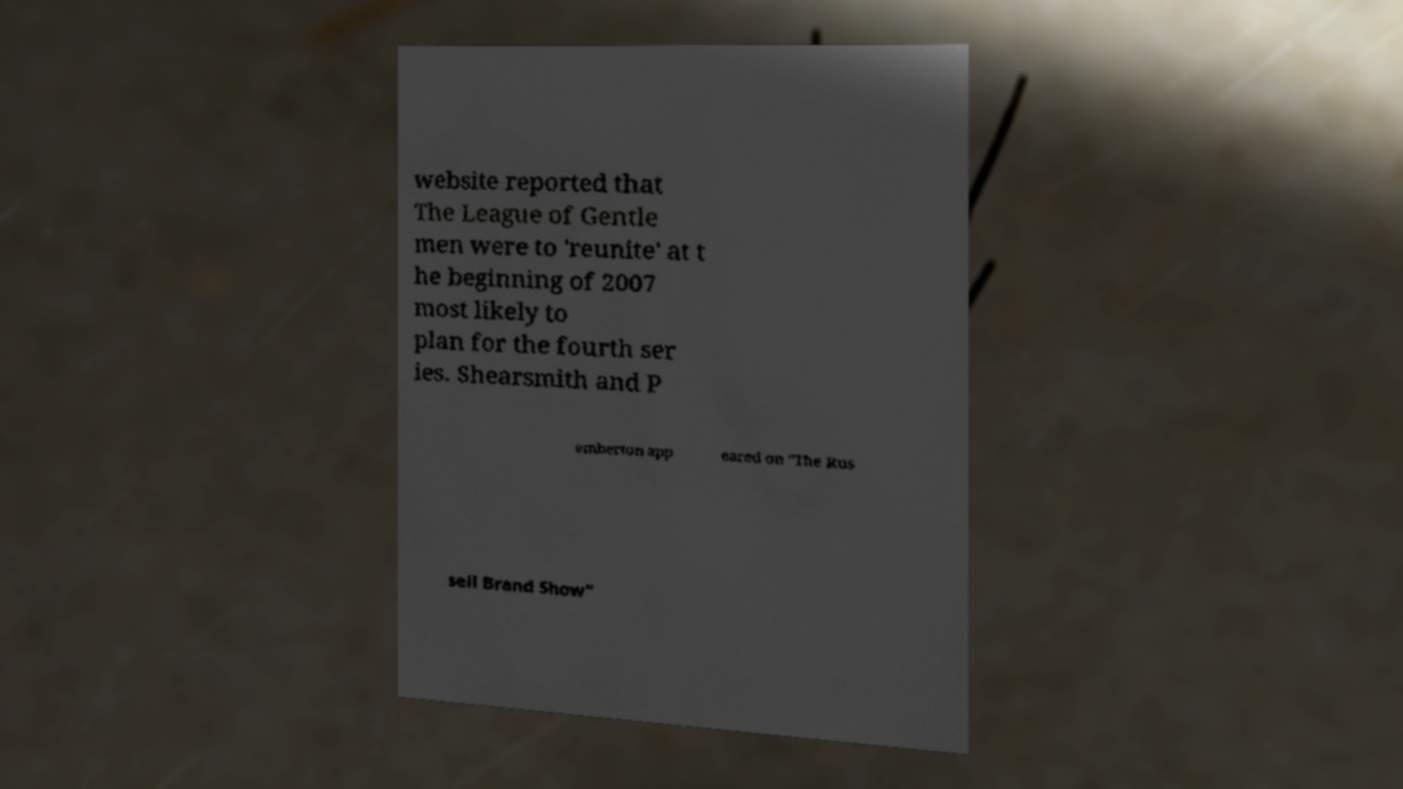For documentation purposes, I need the text within this image transcribed. Could you provide that? website reported that The League of Gentle men were to 'reunite' at t he beginning of 2007 most likely to plan for the fourth ser ies. Shearsmith and P emberton app eared on "The Rus sell Brand Show" 